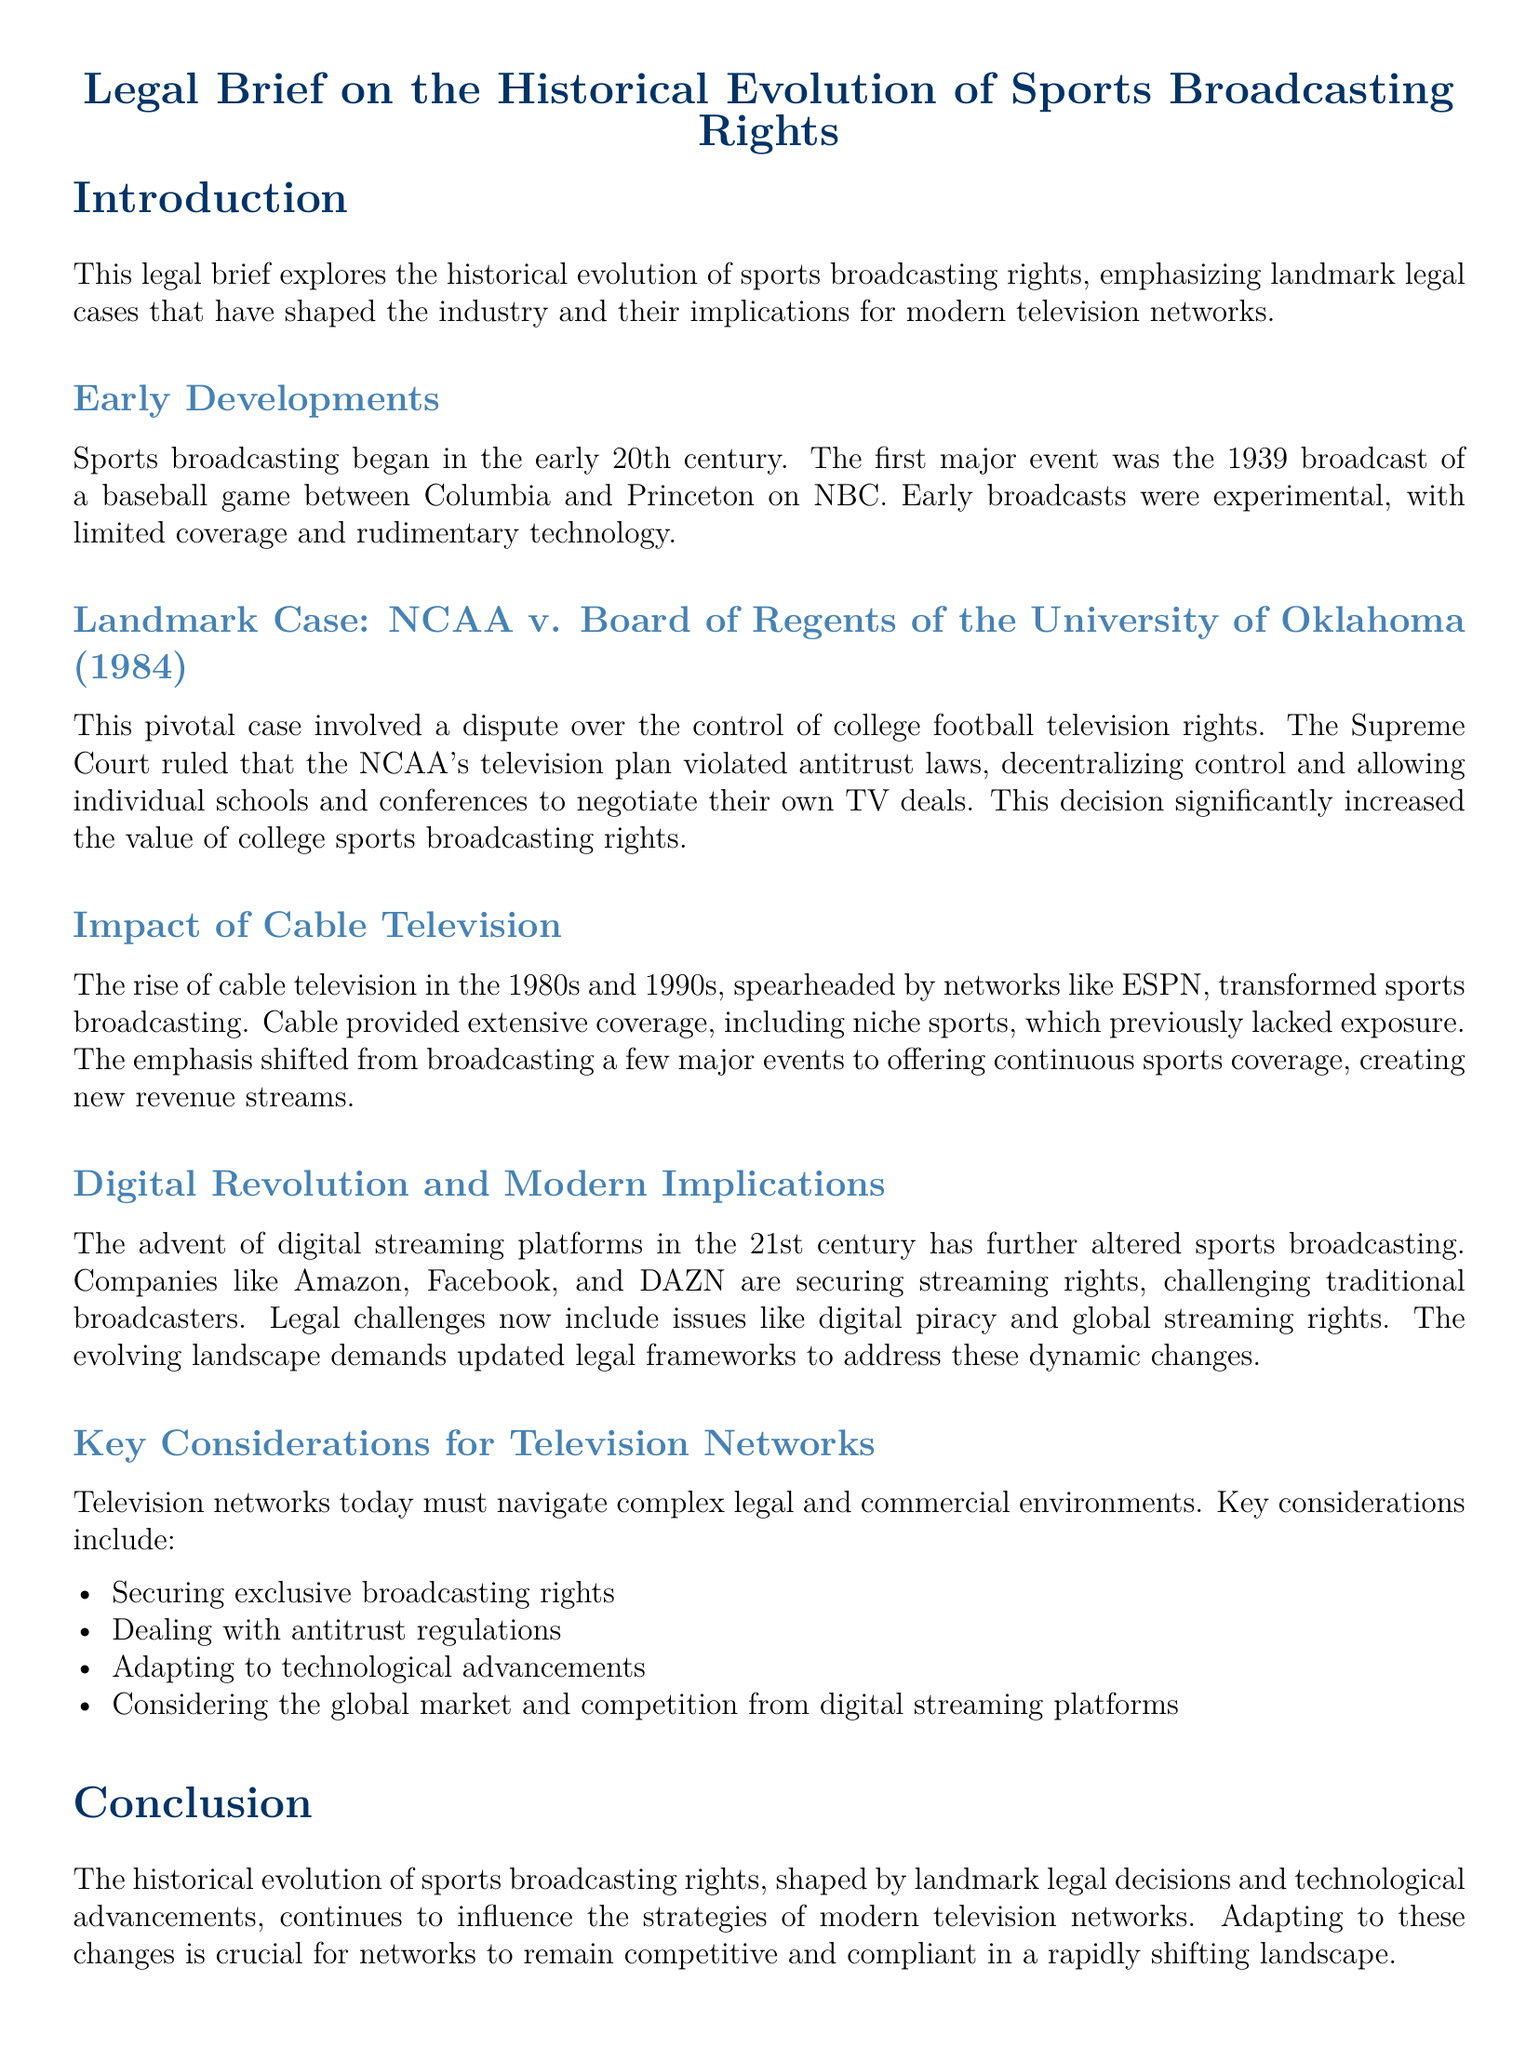What was the first major televised baseball game? The document states the first major event was the 1939 broadcast of a baseball game between Columbia and Princeton on NBC.
Answer: 1939 broadcast of a baseball game between Columbia and Princeton What landmark case involved NCAA and TV rights? The case mentioned in the document is NCAA v. Board of Regents of the University of Oklahoma.
Answer: NCAA v. Board of Regents of the University of Oklahoma What did the Supreme Court rule in the NCAA case? The ruling was that the NCAA's television plan violated antitrust laws, allowing schools to negotiate their own TV deals.
Answer: Violated antitrust laws What major transformation in sports broadcasting occurred in the 1980s and 1990s? The rise of cable television, particularly with networks like ESPN, transformed sports broadcasting by providing extensive coverage.
Answer: Rise of cable television What major technology shift is affecting sports broadcasting today? The document discusses the advent of digital streaming platforms as a significant change in the sports broadcasting landscape.
Answer: Digital streaming platforms What is a key consideration for modern television networks regarding broadcasting rights? Networks must secure exclusive broadcasting rights as a critical aspect of their strategy.
Answer: Securing exclusive broadcasting rights What is a recurring legal challenge in modern sports broadcasting? Issues like digital piracy are highlighted as ongoing legal challenges faced by the industry.
Answer: Digital piracy What impact did the NCAA case have on college sports broadcasting rights? The impact was a significant increase in the value of college sports broadcasting rights through decentralization.
Answer: Significant increase in value What role did ESPN play in the evolution of sports broadcasting? ESPN helped transform sports broadcasting by providing extensive coverage of niche sports.
Answer: Coverage of niche sports 